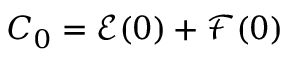<formula> <loc_0><loc_0><loc_500><loc_500>C _ { 0 } = \mathcal { E } ( 0 ) + \mathcal { F } ( 0 )</formula> 